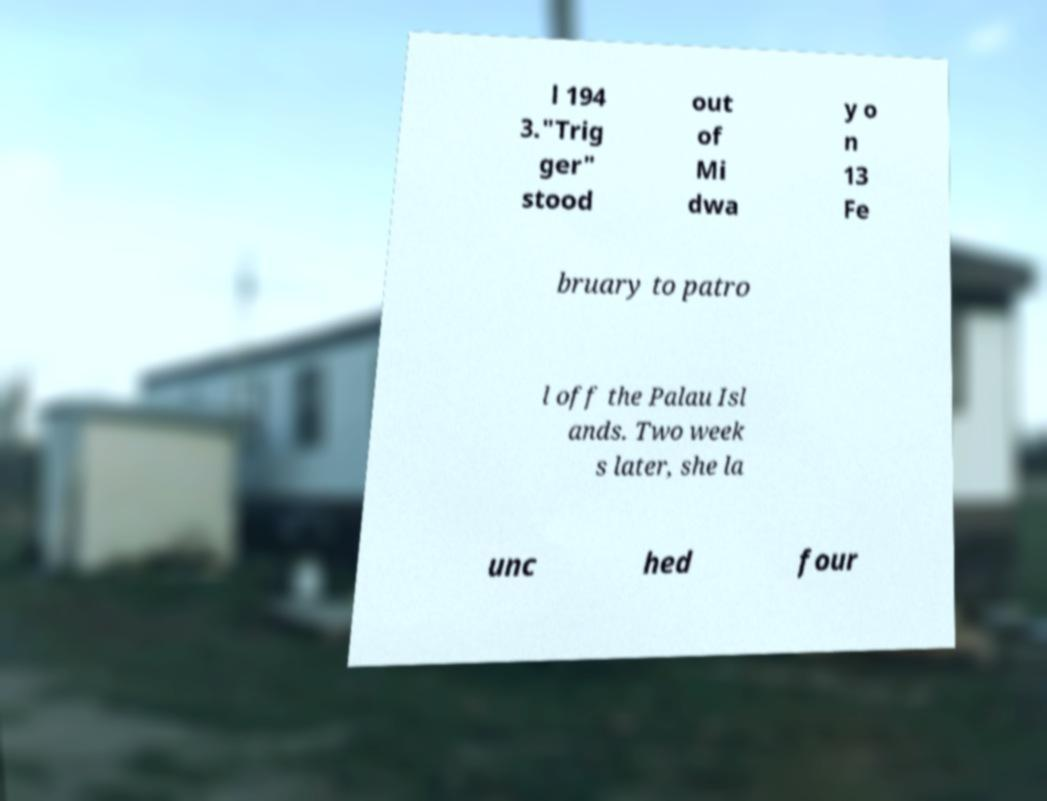Could you extract and type out the text from this image? l 194 3."Trig ger" stood out of Mi dwa y o n 13 Fe bruary to patro l off the Palau Isl ands. Two week s later, she la unc hed four 